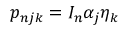Convert formula to latex. <formula><loc_0><loc_0><loc_500><loc_500>p _ { n j k } = I _ { n } \alpha _ { j } \eta _ { k }</formula> 